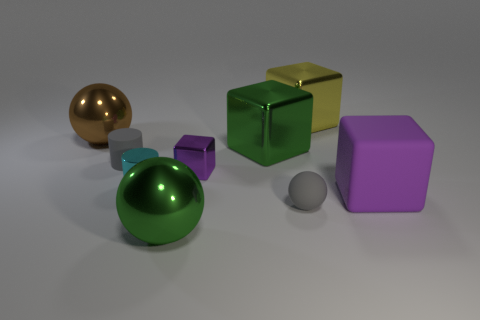What color is the big shiny sphere behind the large green object behind the big matte cube?
Your response must be concise. Brown. What number of blocks are large shiny things or big rubber objects?
Ensure brevity in your answer.  3. What number of large objects are behind the big brown thing and in front of the rubber cube?
Make the answer very short. 0. There is a tiny rubber object that is on the left side of the big green metal sphere; what color is it?
Provide a short and direct response. Gray. What is the size of the brown sphere that is the same material as the yellow object?
Your answer should be compact. Large. How many gray objects are in front of the small matte object to the right of the cyan metal cylinder?
Offer a terse response. 0. There is a small cyan shiny cylinder; what number of small rubber things are to the left of it?
Offer a very short reply. 1. There is a small metal cylinder to the left of the metallic object in front of the small cylinder that is in front of the purple metal cube; what is its color?
Your response must be concise. Cyan. There is a large metallic cube that is in front of the brown shiny object; is it the same color as the big ball that is in front of the rubber ball?
Offer a terse response. Yes. There is a big green shiny thing that is behind the purple thing on the right side of the large yellow cube; what is its shape?
Your answer should be compact. Cube. 